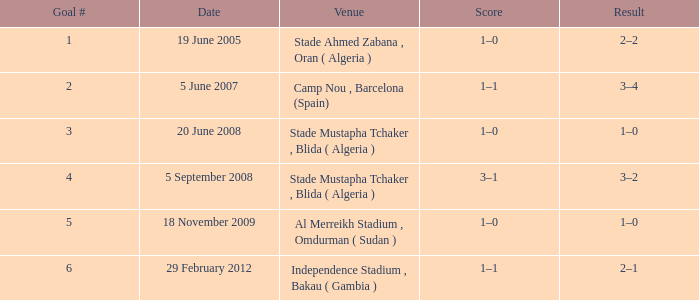Would you be able to parse every entry in this table? {'header': ['Goal #', 'Date', 'Venue', 'Score', 'Result'], 'rows': [['1', '19 June 2005', 'Stade Ahmed Zabana , Oran ( Algeria )', '1–0', '2–2'], ['2', '5 June 2007', 'Camp Nou , Barcelona (Spain)', '1–1', '3–4'], ['3', '20 June 2008', 'Stade Mustapha Tchaker , Blida ( Algeria )', '1–0', '1–0'], ['4', '5 September 2008', 'Stade Mustapha Tchaker , Blida ( Algeria )', '3–1', '3–2'], ['5', '18 November 2009', 'Al Merreikh Stadium , Omdurman ( Sudan )', '1–0', '1–0'], ['6', '29 February 2012', 'Independence Stadium , Bakau ( Gambia )', '1–1', '2–1']]} What was the venue where goal #2 occured? Camp Nou , Barcelona (Spain). 